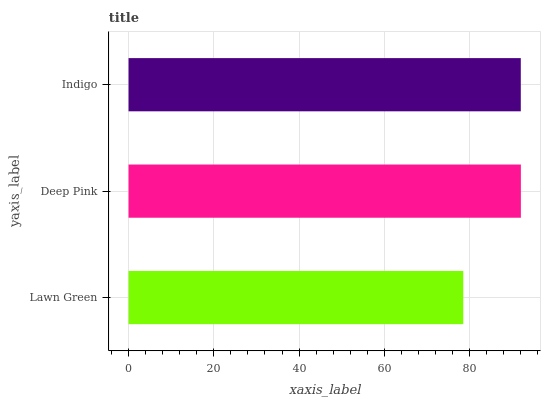Is Lawn Green the minimum?
Answer yes or no. Yes. Is Deep Pink the maximum?
Answer yes or no. Yes. Is Indigo the minimum?
Answer yes or no. No. Is Indigo the maximum?
Answer yes or no. No. Is Deep Pink greater than Indigo?
Answer yes or no. Yes. Is Indigo less than Deep Pink?
Answer yes or no. Yes. Is Indigo greater than Deep Pink?
Answer yes or no. No. Is Deep Pink less than Indigo?
Answer yes or no. No. Is Indigo the high median?
Answer yes or no. Yes. Is Indigo the low median?
Answer yes or no. Yes. Is Deep Pink the high median?
Answer yes or no. No. Is Lawn Green the low median?
Answer yes or no. No. 